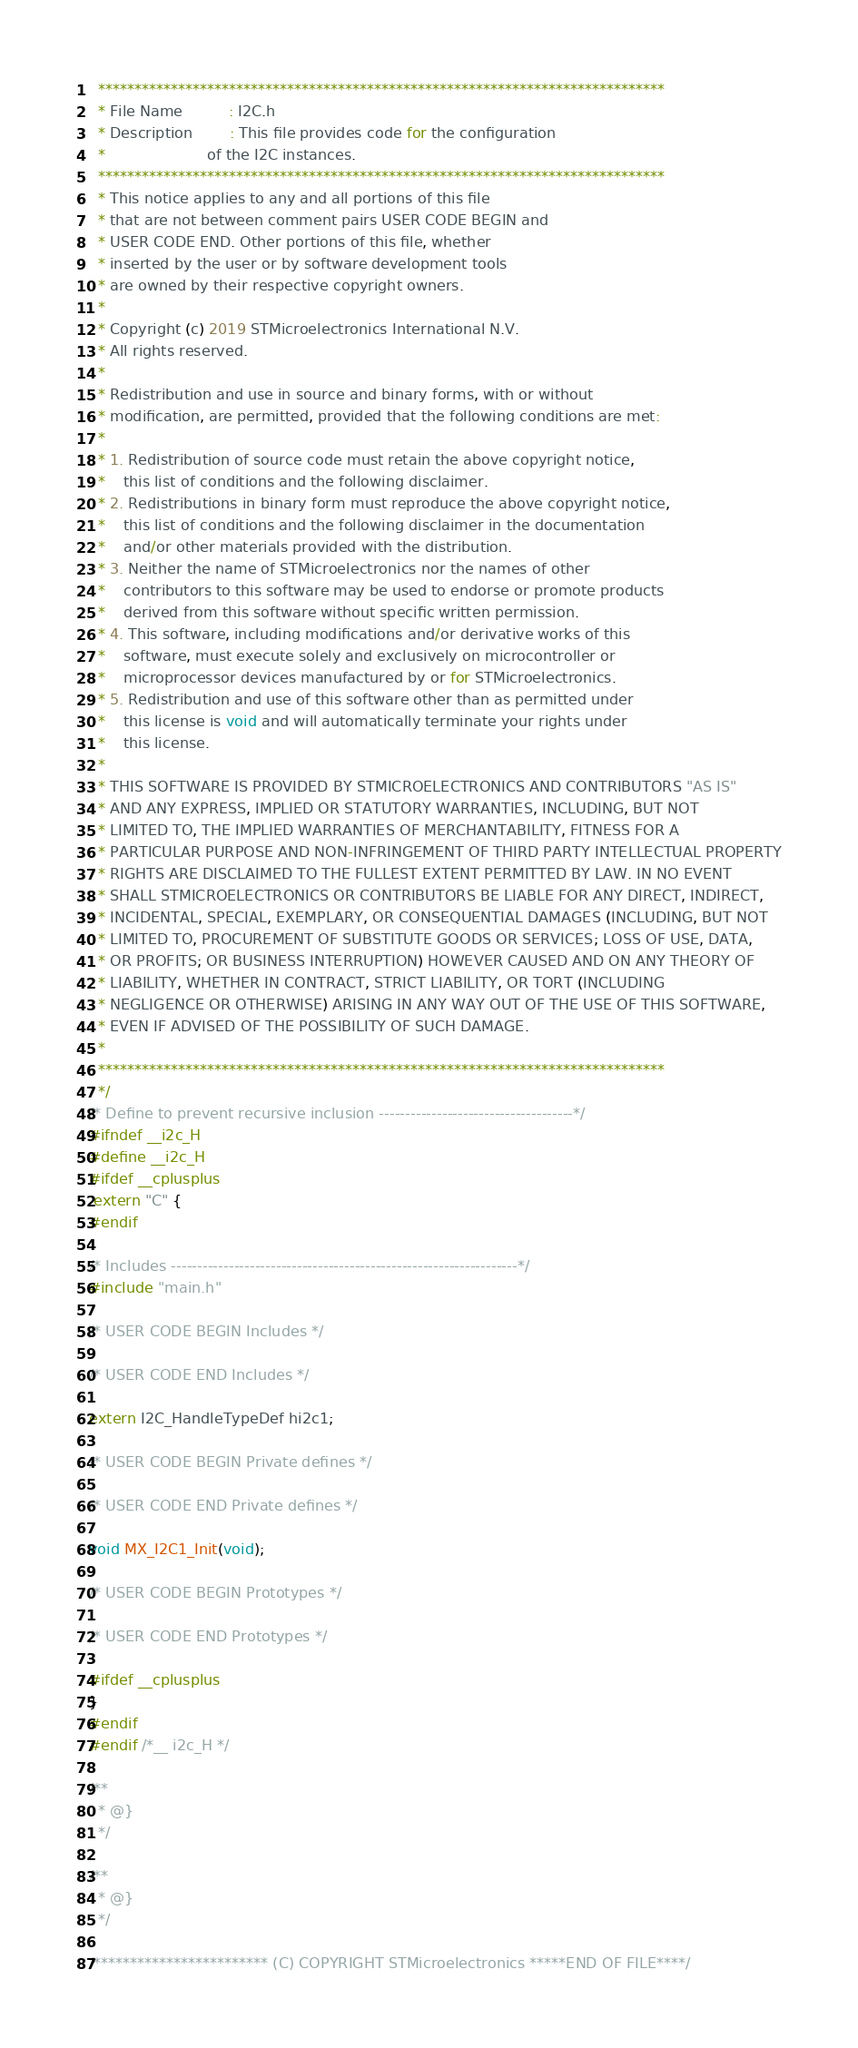Convert code to text. <code><loc_0><loc_0><loc_500><loc_500><_C_>  ******************************************************************************
  * File Name          : I2C.h
  * Description        : This file provides code for the configuration
  *                      of the I2C instances.
  ******************************************************************************
  * This notice applies to any and all portions of this file
  * that are not between comment pairs USER CODE BEGIN and
  * USER CODE END. Other portions of this file, whether 
  * inserted by the user or by software development tools
  * are owned by their respective copyright owners.
  *
  * Copyright (c) 2019 STMicroelectronics International N.V. 
  * All rights reserved.
  *
  * Redistribution and use in source and binary forms, with or without 
  * modification, are permitted, provided that the following conditions are met:
  *
  * 1. Redistribution of source code must retain the above copyright notice, 
  *    this list of conditions and the following disclaimer.
  * 2. Redistributions in binary form must reproduce the above copyright notice,
  *    this list of conditions and the following disclaimer in the documentation
  *    and/or other materials provided with the distribution.
  * 3. Neither the name of STMicroelectronics nor the names of other 
  *    contributors to this software may be used to endorse or promote products 
  *    derived from this software without specific written permission.
  * 4. This software, including modifications and/or derivative works of this 
  *    software, must execute solely and exclusively on microcontroller or
  *    microprocessor devices manufactured by or for STMicroelectronics.
  * 5. Redistribution and use of this software other than as permitted under 
  *    this license is void and will automatically terminate your rights under 
  *    this license. 
  *
  * THIS SOFTWARE IS PROVIDED BY STMICROELECTRONICS AND CONTRIBUTORS "AS IS" 
  * AND ANY EXPRESS, IMPLIED OR STATUTORY WARRANTIES, INCLUDING, BUT NOT 
  * LIMITED TO, THE IMPLIED WARRANTIES OF MERCHANTABILITY, FITNESS FOR A 
  * PARTICULAR PURPOSE AND NON-INFRINGEMENT OF THIRD PARTY INTELLECTUAL PROPERTY
  * RIGHTS ARE DISCLAIMED TO THE FULLEST EXTENT PERMITTED BY LAW. IN NO EVENT 
  * SHALL STMICROELECTRONICS OR CONTRIBUTORS BE LIABLE FOR ANY DIRECT, INDIRECT,
  * INCIDENTAL, SPECIAL, EXEMPLARY, OR CONSEQUENTIAL DAMAGES (INCLUDING, BUT NOT
  * LIMITED TO, PROCUREMENT OF SUBSTITUTE GOODS OR SERVICES; LOSS OF USE, DATA, 
  * OR PROFITS; OR BUSINESS INTERRUPTION) HOWEVER CAUSED AND ON ANY THEORY OF 
  * LIABILITY, WHETHER IN CONTRACT, STRICT LIABILITY, OR TORT (INCLUDING 
  * NEGLIGENCE OR OTHERWISE) ARISING IN ANY WAY OUT OF THE USE OF THIS SOFTWARE,
  * EVEN IF ADVISED OF THE POSSIBILITY OF SUCH DAMAGE.
  *
  ******************************************************************************
  */
/* Define to prevent recursive inclusion -------------------------------------*/
#ifndef __i2c_H
#define __i2c_H
#ifdef __cplusplus
 extern "C" {
#endif

/* Includes ------------------------------------------------------------------*/
#include "main.h"

/* USER CODE BEGIN Includes */

/* USER CODE END Includes */

extern I2C_HandleTypeDef hi2c1;

/* USER CODE BEGIN Private defines */

/* USER CODE END Private defines */

void MX_I2C1_Init(void);

/* USER CODE BEGIN Prototypes */

/* USER CODE END Prototypes */

#ifdef __cplusplus
}
#endif
#endif /*__ i2c_H */

/**
  * @}
  */

/**
  * @}
  */

/************************ (C) COPYRIGHT STMicroelectronics *****END OF FILE****/
</code> 